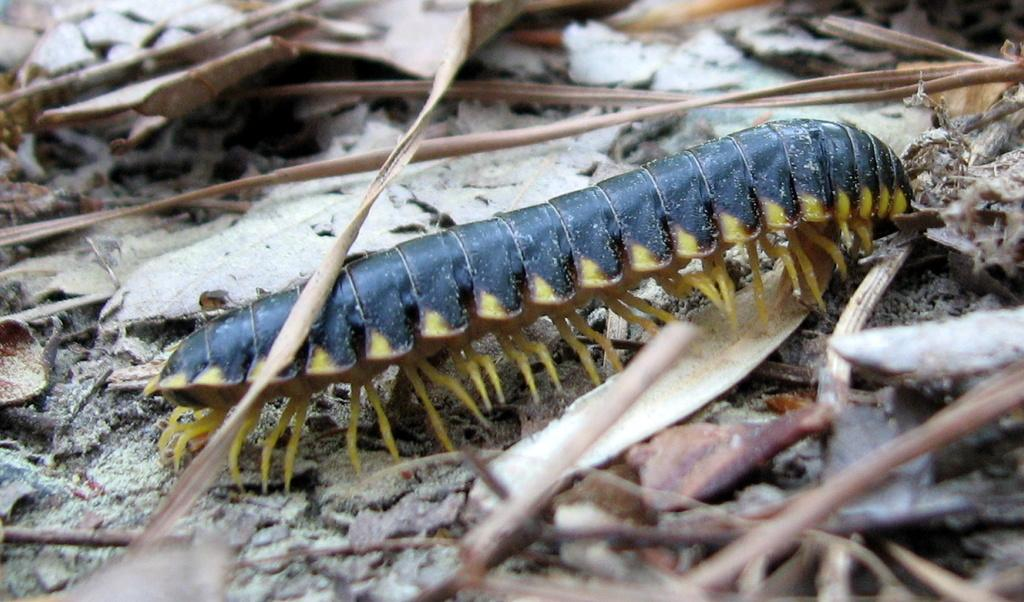What type of creature can be seen in the image? There is an insect in the image. Where is the insect located? The insect is on the ground. What can be seen in the background of the image? There are dried leaves in the background of the image. What note is the beggar playing on the orange in the image? There is no beggar or orange present in the image; it only features an insect on the ground and dried leaves in the background. 